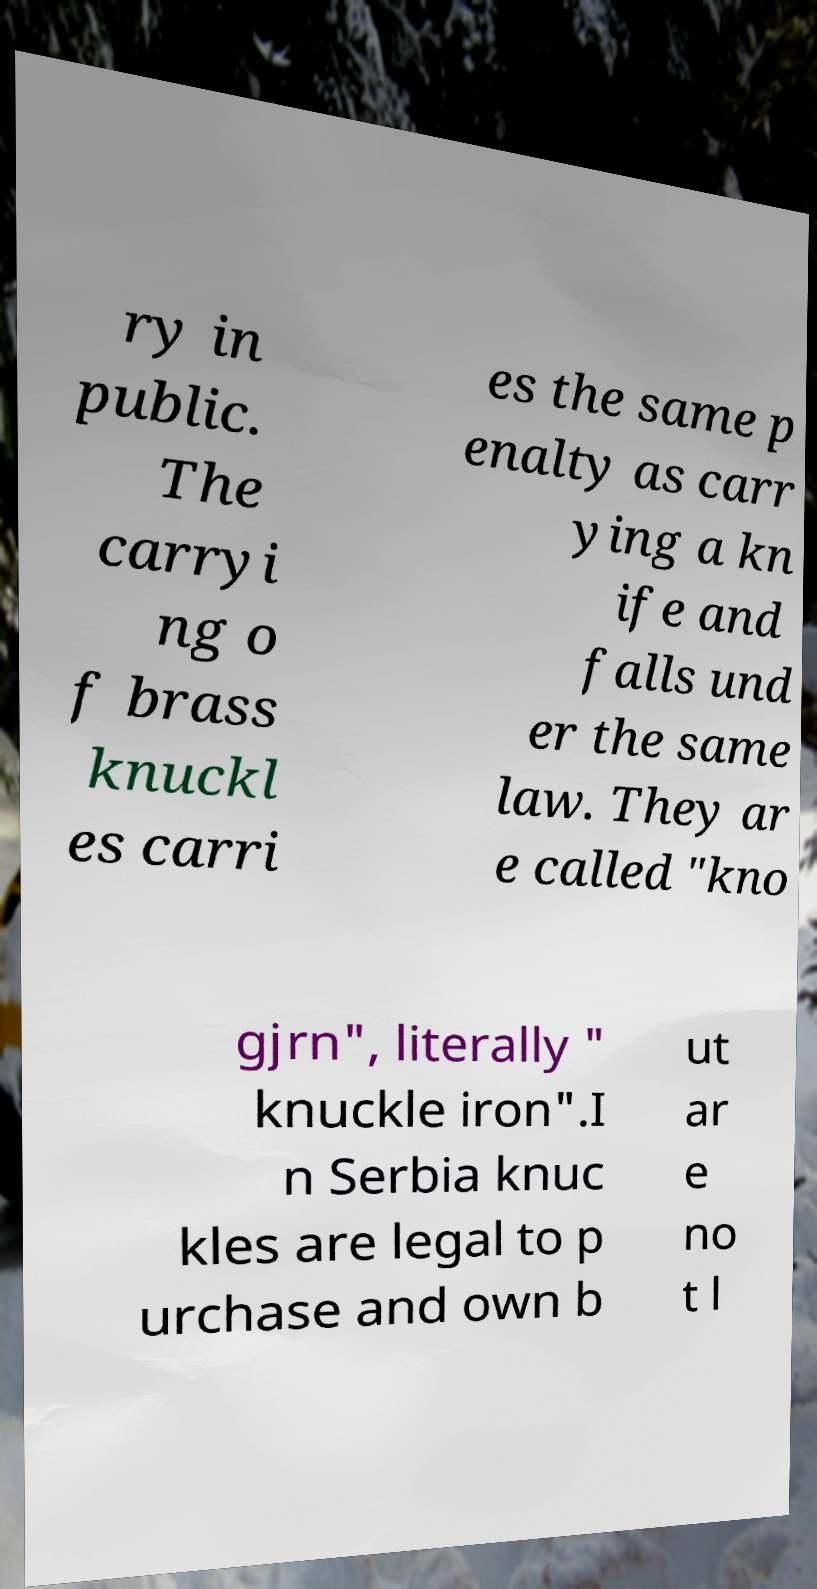Please read and relay the text visible in this image. What does it say? ry in public. The carryi ng o f brass knuckl es carri es the same p enalty as carr ying a kn ife and falls und er the same law. They ar e called "kno gjrn", literally " knuckle iron".I n Serbia knuc kles are legal to p urchase and own b ut ar e no t l 